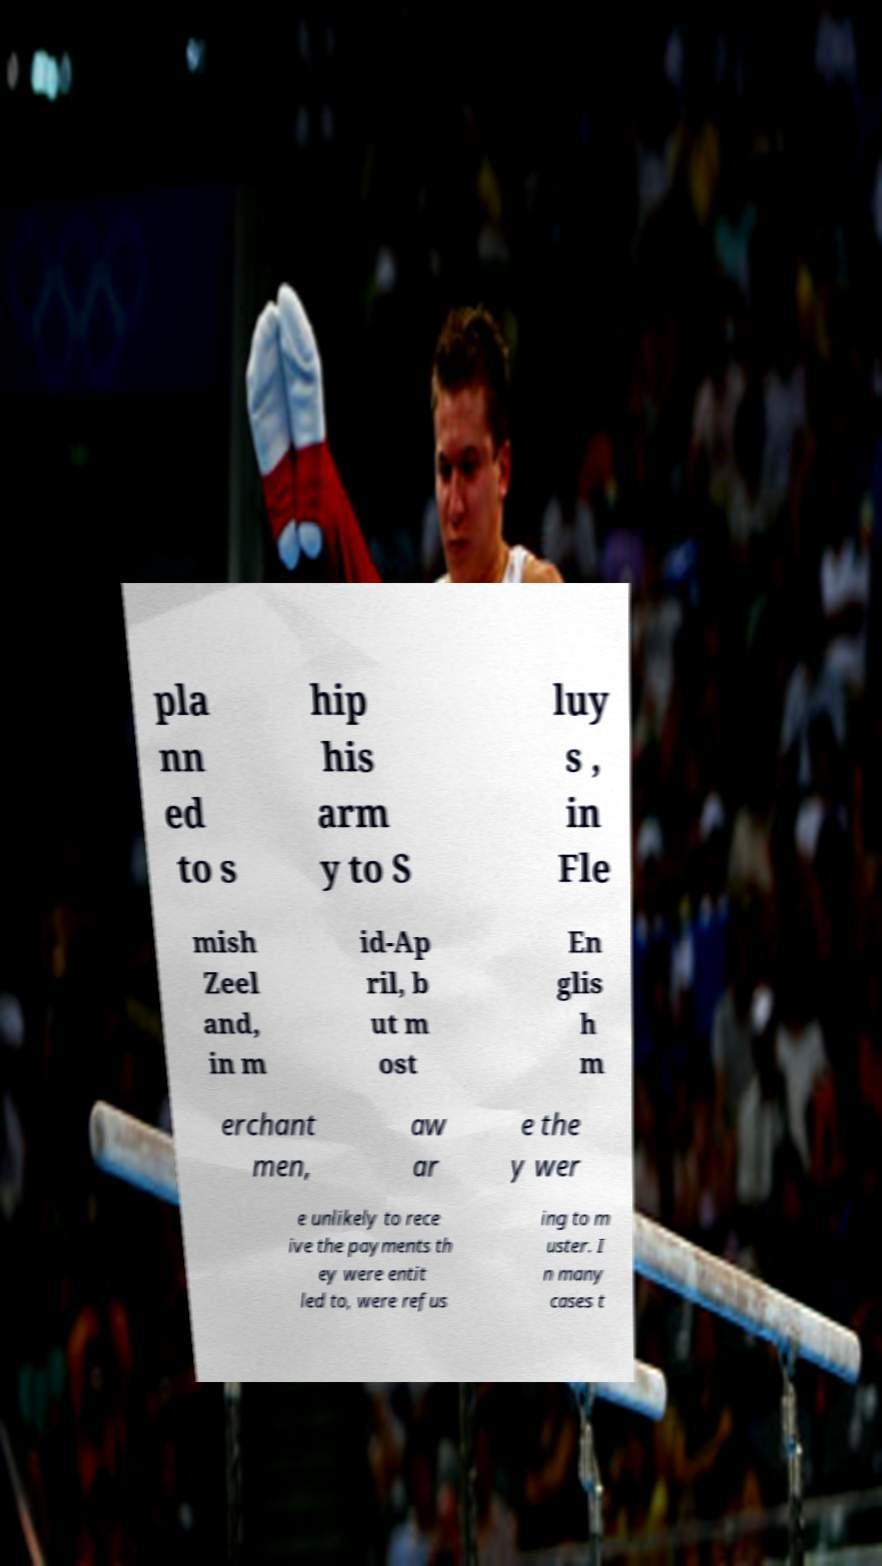Please identify and transcribe the text found in this image. pla nn ed to s hip his arm y to S luy s , in Fle mish Zeel and, in m id-Ap ril, b ut m ost En glis h m erchant men, aw ar e the y wer e unlikely to rece ive the payments th ey were entit led to, were refus ing to m uster. I n many cases t 